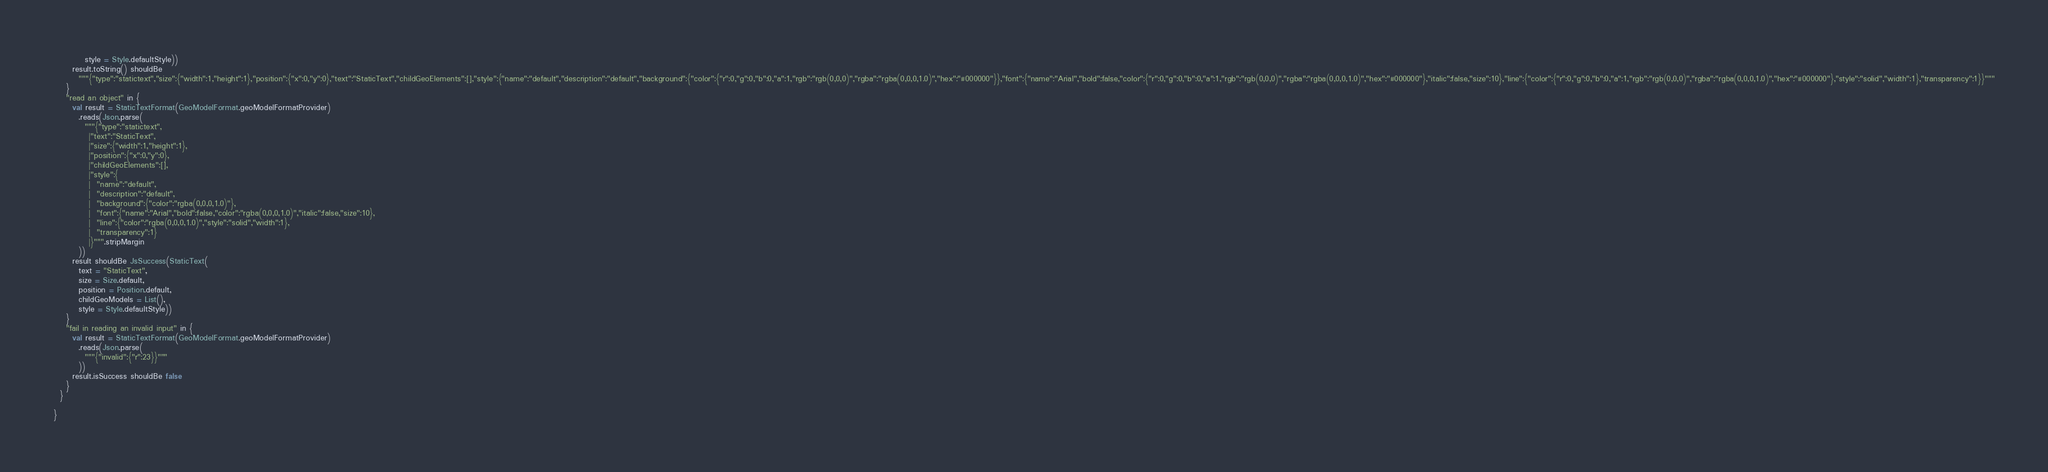Convert code to text. <code><loc_0><loc_0><loc_500><loc_500><_Scala_>          style = Style.defaultStyle))
      result.toString() shouldBe
        """{"type":"statictext","size":{"width":1,"height":1},"position":{"x":0,"y":0},"text":"StaticText","childGeoElements":[],"style":{"name":"default","description":"default","background":{"color":{"r":0,"g":0,"b":0,"a":1,"rgb":"rgb(0,0,0)","rgba":"rgba(0,0,0,1.0)","hex":"#000000"}},"font":{"name":"Arial","bold":false,"color":{"r":0,"g":0,"b":0,"a":1,"rgb":"rgb(0,0,0)","rgba":"rgba(0,0,0,1.0)","hex":"#000000"},"italic":false,"size":10},"line":{"color":{"r":0,"g":0,"b":0,"a":1,"rgb":"rgb(0,0,0)","rgba":"rgba(0,0,0,1.0)","hex":"#000000"},"style":"solid","width":1},"transparency":1}}"""
    }
    "read an object" in {
      val result = StaticTextFormat(GeoModelFormat.geoModelFormatProvider)
        .reads(Json.parse(
          """{"type":"statictext",
           |"text":"StaticText",
           |"size":{"width":1,"height":1},
           |"position":{"x":0,"y":0},
           |"childGeoElements":[],
           |"style":{
           |  "name":"default",
           |  "description":"default",
           |  "background":{"color":"rgba(0,0,0,1.0)"},
           |  "font":{"name":"Arial","bold":false,"color":"rgba(0,0,0,1.0)","italic":false,"size":10},
           |  "line":{"color":"rgba(0,0,0,1.0)","style":"solid","width":1},
           |  "transparency":1}
           |}""".stripMargin
        ))
      result shouldBe JsSuccess(StaticText(
        text = "StaticText",
        size = Size.default,
        position = Position.default,
        childGeoModels = List(),
        style = Style.defaultStyle))
    }
    "fail in reading an invalid input" in {
      val result = StaticTextFormat(GeoModelFormat.geoModelFormatProvider)
        .reads(Json.parse(
          """{"invalid":{"r":23}}"""
        ))
      result.isSuccess shouldBe false
    }
  }

}
</code> 